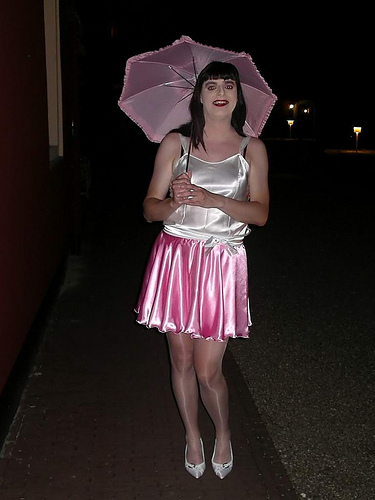<image>
Can you confirm if the skirt is next to the parasol? No. The skirt is not positioned next to the parasol. They are located in different areas of the scene. 